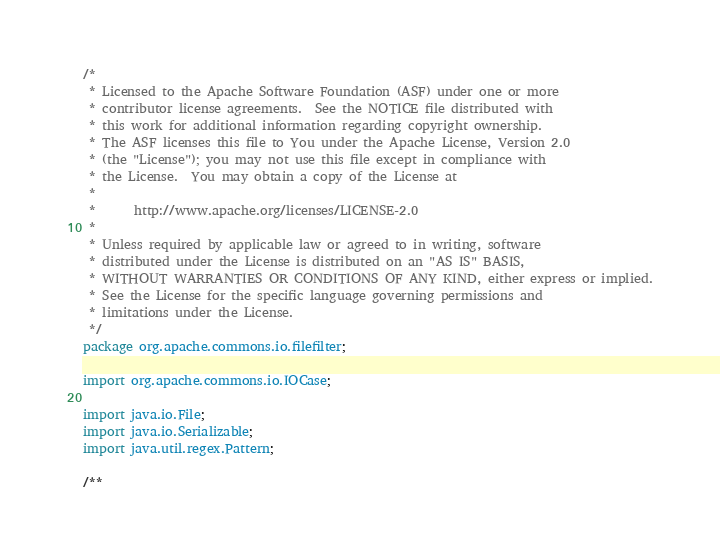<code> <loc_0><loc_0><loc_500><loc_500><_Java_>/*
 * Licensed to the Apache Software Foundation (ASF) under one or more
 * contributor license agreements.  See the NOTICE file distributed with
 * this work for additional information regarding copyright ownership.
 * The ASF licenses this file to You under the Apache License, Version 2.0
 * (the "License"); you may not use this file except in compliance with
 * the License.  You may obtain a copy of the License at
 * 
 *      http://www.apache.org/licenses/LICENSE-2.0
 * 
 * Unless required by applicable law or agreed to in writing, software
 * distributed under the License is distributed on an "AS IS" BASIS,
 * WITHOUT WARRANTIES OR CONDITIONS OF ANY KIND, either express or implied.
 * See the License for the specific language governing permissions and
 * limitations under the License.
 */
package org.apache.commons.io.filefilter;

import org.apache.commons.io.IOCase;

import java.io.File;
import java.io.Serializable;
import java.util.regex.Pattern;

/**</code> 